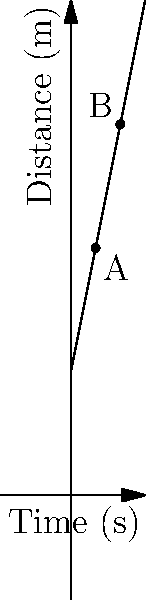The distance-time graph shows the motion of a soccer ball kicked by a student. Point A represents the ball's position after 2 seconds, and point B represents its position after 4 seconds. Calculate the average velocity of the ball between points A and B. How could this information be used to discuss teamwork in passing the ball effectively? To calculate the average velocity, we need to determine the change in distance and the change in time between points A and B. Let's follow these steps:

1. Identify the coordinates of points A and B:
   Point A: (2 s, 20 m)
   Point B: (4 s, 30 m)

2. Calculate the change in distance (displacement):
   $$\Delta d = d_B - d_A = 30 \text{ m} - 20 \text{ m} = 10 \text{ m}$$

3. Calculate the change in time:
   $$\Delta t = t_B - t_A = 4 \text{ s} - 2 \text{ s} = 2 \text{ s}$$

4. Use the formula for average velocity:
   $$v_{avg} = \frac{\Delta d}{\Delta t} = \frac{10 \text{ m}}{2 \text{ s}} = 5 \text{ m/s}$$

The average velocity of the ball between points A and B is 5 m/s.

This information can be used to discuss teamwork in passing the ball effectively by:
1. Emphasizing the importance of consistent ball speed for accurate passing.
2. Discussing how players need to anticipate the ball's arrival based on its velocity.
3. Exploring how different passing speeds can be used strategically in gameplay.
4. Encouraging students to practice passing at various velocities to improve team coordination.
Answer: 5 m/s 